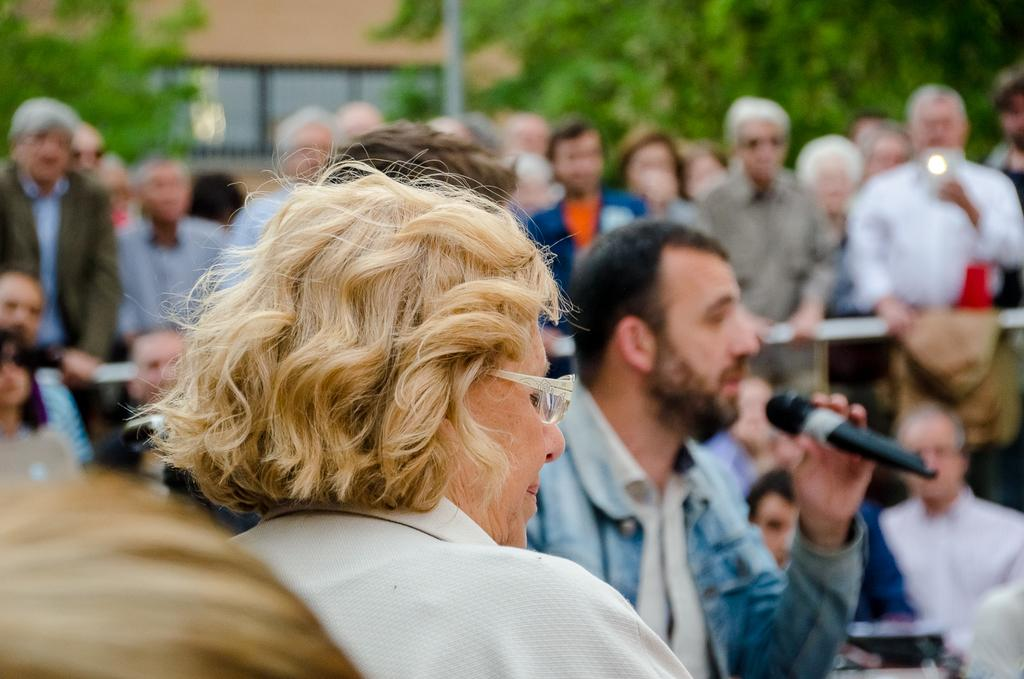What is the person in the image wearing on their face? The person in the image is wearing white color spectacles. What is the man in the image holding? The man in the image is holding a mike. What can be seen in the background of the image? There is a group of people, a building, a pole, and a tree in the background of the image. How many letters are visible on the pole in the image? There are no letters visible on the pole in the image. What type of loss is depicted in the image? There is no loss depicted in the image; it features a person with spectacles, a man holding a mike, and a group of people, building, pole, and tree in the background. 